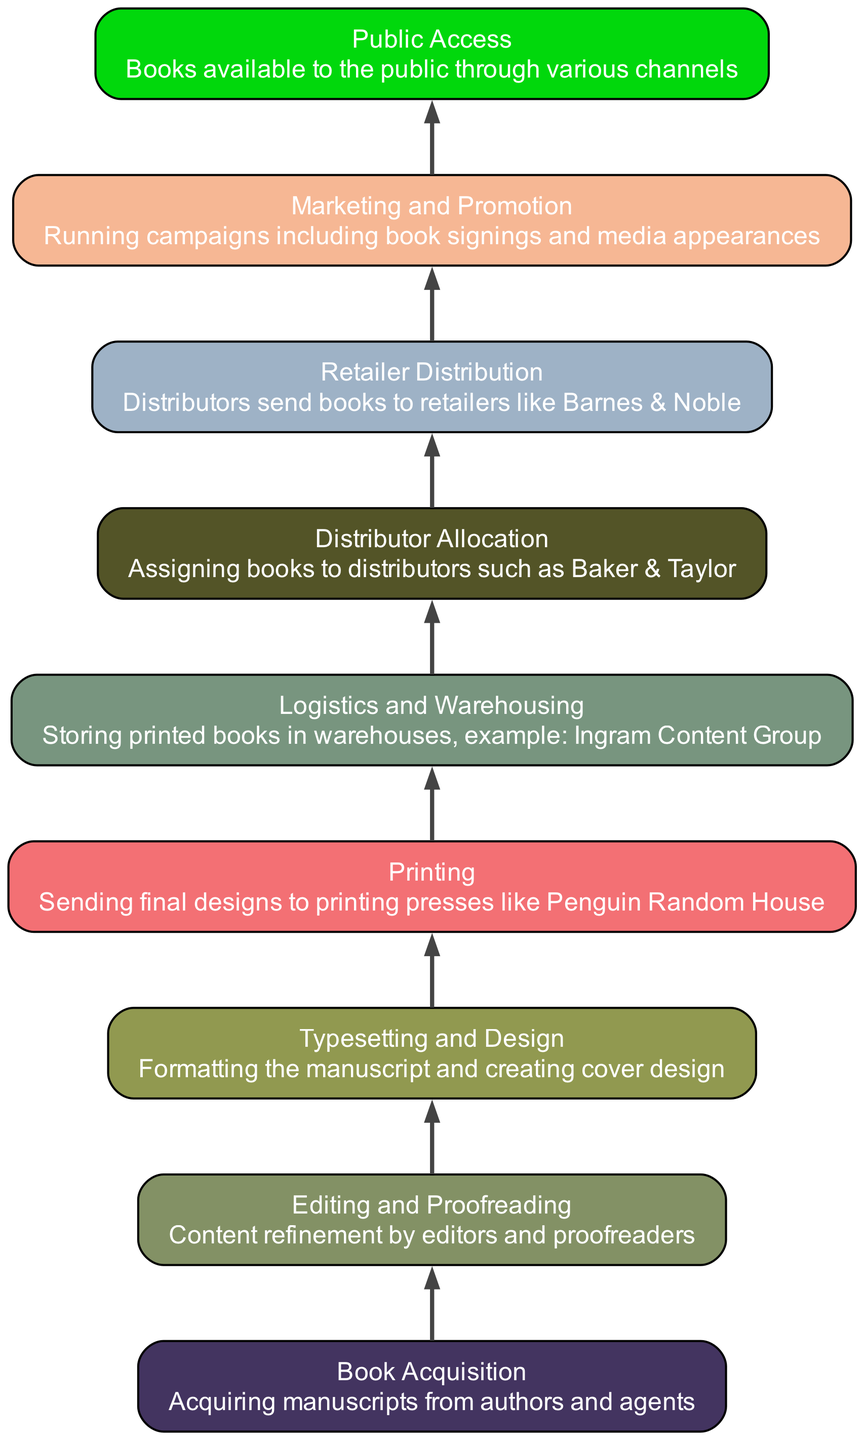What is the first step in the distribution network setup? The first step in the flow chart is "Book Acquisition," which involves acquiring manuscripts from authors and agents. This can be seen as the entry point of the process before any other steps occur.
Answer: Book Acquisition How many nodes are present in the diagram? There are nine nodes in the flow chart, each representing a key step in the distribution network setup. This can be confirmed by counting each distinct element listed in the data.
Answer: Nine What step follows "Marketing and Promotion"? The step that follows "Marketing and Promotion" is "Public Access," indicating that after marketing efforts are undertaken, the books become available to the public through various channels.
Answer: Public Access Which step involves "storing printed books in warehouses"? The step that involves "storing printed books in warehouses" is "Logistics and Warehousing." This step is crucial for managing inventory and preparing for distribution to retailers.
Answer: Logistics and Warehousing What is the connection between "Printing" and "Distributor Allocation"? "Printing" leads directly to "Distributor Allocation," meaning that once the books are printed, they are then assigned to distributors for further distribution steps. This shows the sequential flow from one process to the next.
Answer: Direct connection Which step involves "assigning books to distributors"? The step that involves "assigning books to distributors" is "Distributor Allocation." It focuses on the strategic decision to allocate printed books to various distributors for efficient market reach.
Answer: Distributor Allocation How does "Typesetting and Design" relate to "Public Access"? "Typesetting and Design" is an earlier step that precedes "Public Access." The flow indicates that once a book is typeset and designed, it moves through printing and distribution before reaching public access. Therefore, understanding the relationship illustrates the chain of processes leading to public availability.
Answer: Indirect relationship through multiple steps What node represents the refinement of the manuscript? The node that represents the refinement of the manuscript is "Editing and Proofreading." This step is critical in ensuring the quality and integrity of the book content before it goes to typesetting and design.
Answer: Editing and Proofreading Which distributor is mentioned in the "Distributor Allocation" step? The distributor mentioned in the "Distributor Allocation" step is "Baker & Taylor." This indicates a specific choice of distributor in the overall distribution strategy for the published books.
Answer: Baker & Taylor 